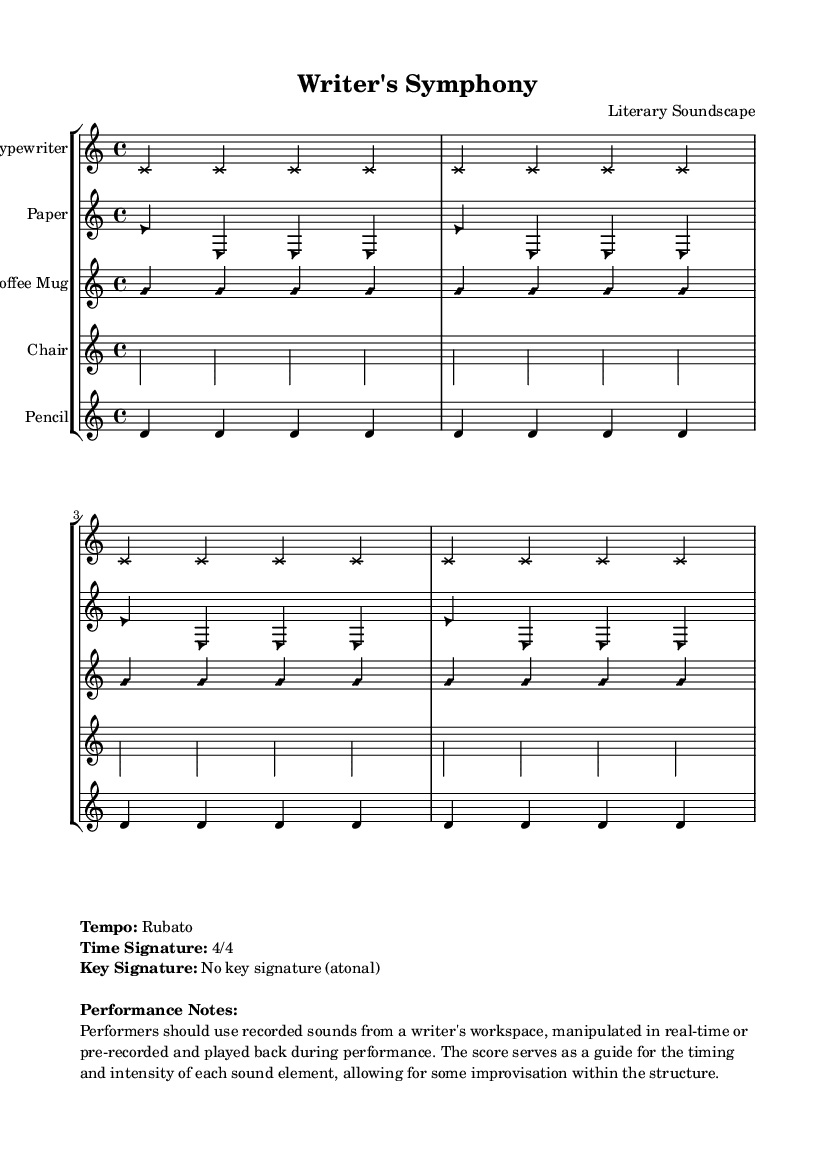What is the title of this piece? The title is displayed prominently at the top of the sheet music under the header section.
Answer: Writer's Symphony What is the time signature of this music? The time signature is indicated near the performance notes section of the markup, stating that it is '4/4'.
Answer: 4/4 What is the tempo marking for this piece? The tempo is noted in the performance notes within the markup area, which indicates that it should be performed rubato.
Answer: Rubato How many distinct sound sources are indicated in the score? By counting the individual staves listed in the staff group, it shows a total of five sound sources.
Answer: Five What type of musical form does this piece suggest? This piece represents an experimental composition, as indicated by the uniqueness of sound sources and instructions for manipulation, allowing for improvisation.
Answer: Experimental What kind of improvisation is allowed in this piece? The performance notes specify that the sounds can be manipulated in real-time or pre-recorded, indicating a flexible approach to improvisation.
Answer: Real-time or pre-recorded Which sound source is represented with a diamond note head? By examining the notation for note head styles, the coffee mug sound source is indicated by a diamond shape.
Answer: Coffee Mug 